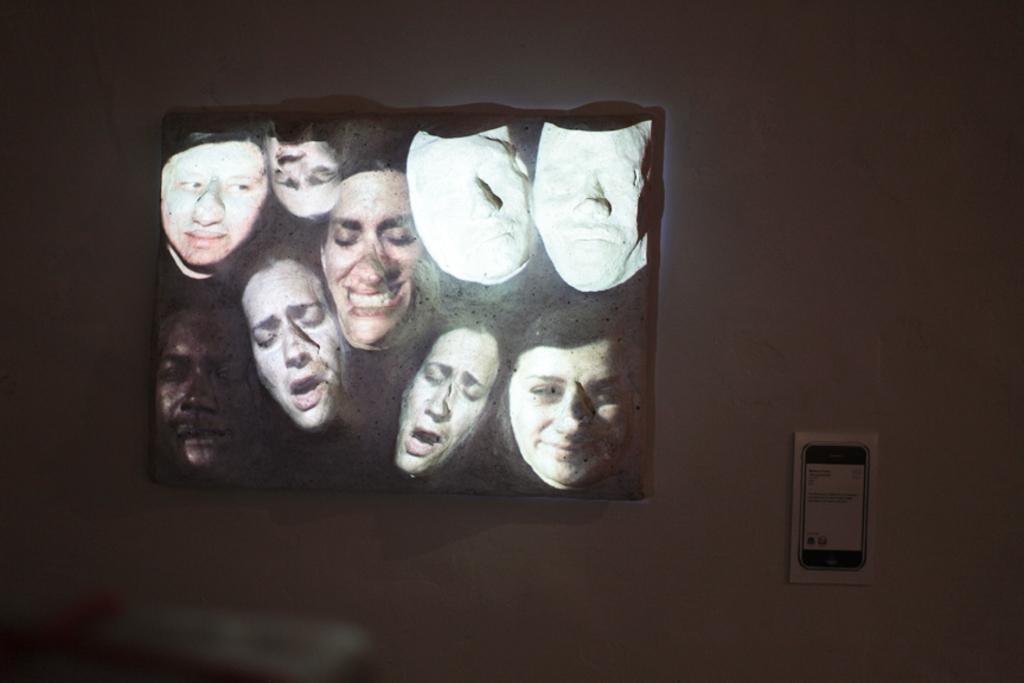Can you describe this image briefly? In this image we can see painting of few persons heads and masks on a board on the wall and on the right side there is an object on the wall. At the bottom on the left side we can see an object is blur. 